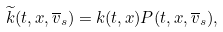<formula> <loc_0><loc_0><loc_500><loc_500>\widetilde { k } ( t , x , \overline { v } _ { s } ) = k ( t , x ) P ( t , x , \overline { v } _ { s } ) ,</formula> 